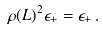<formula> <loc_0><loc_0><loc_500><loc_500>\rho ( L ) ^ { 2 } \epsilon _ { + } = \epsilon _ { + } \, .</formula> 